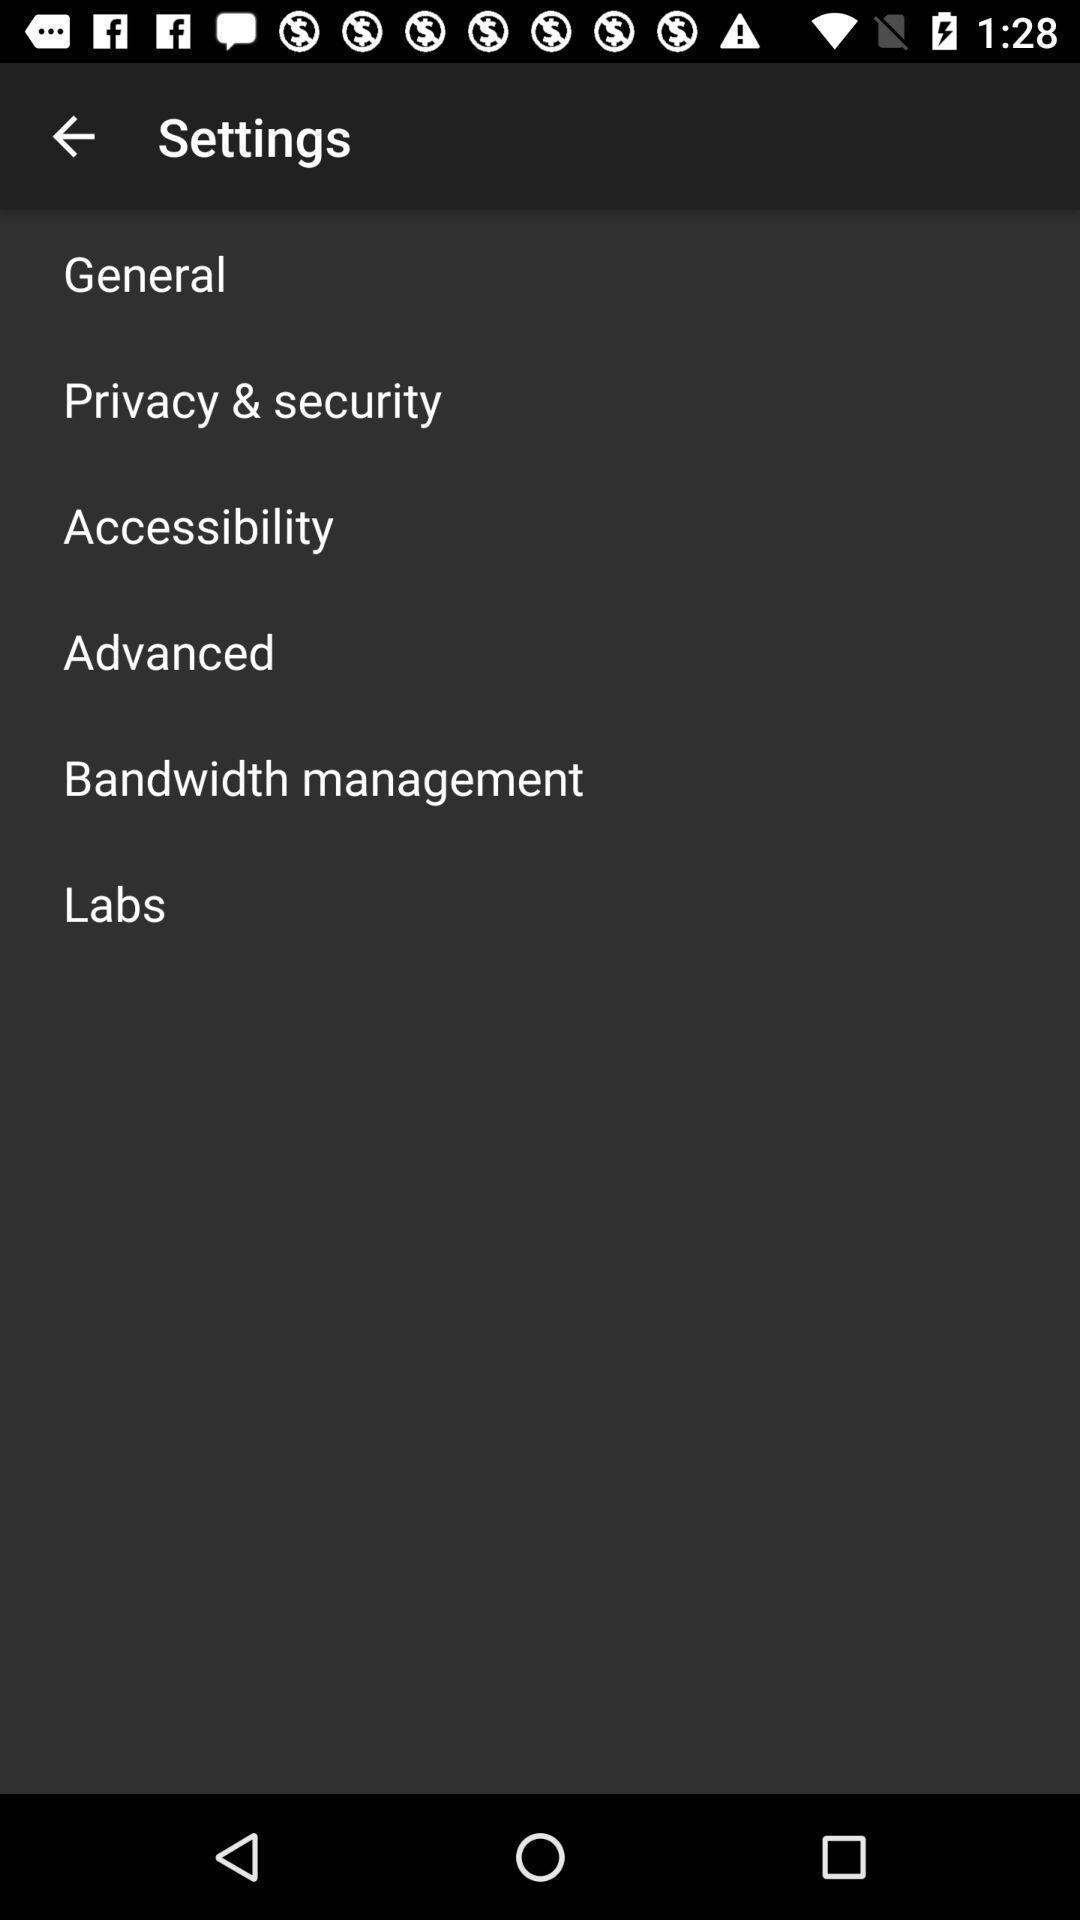Summarize the main components in this picture. Settings page with various options. 